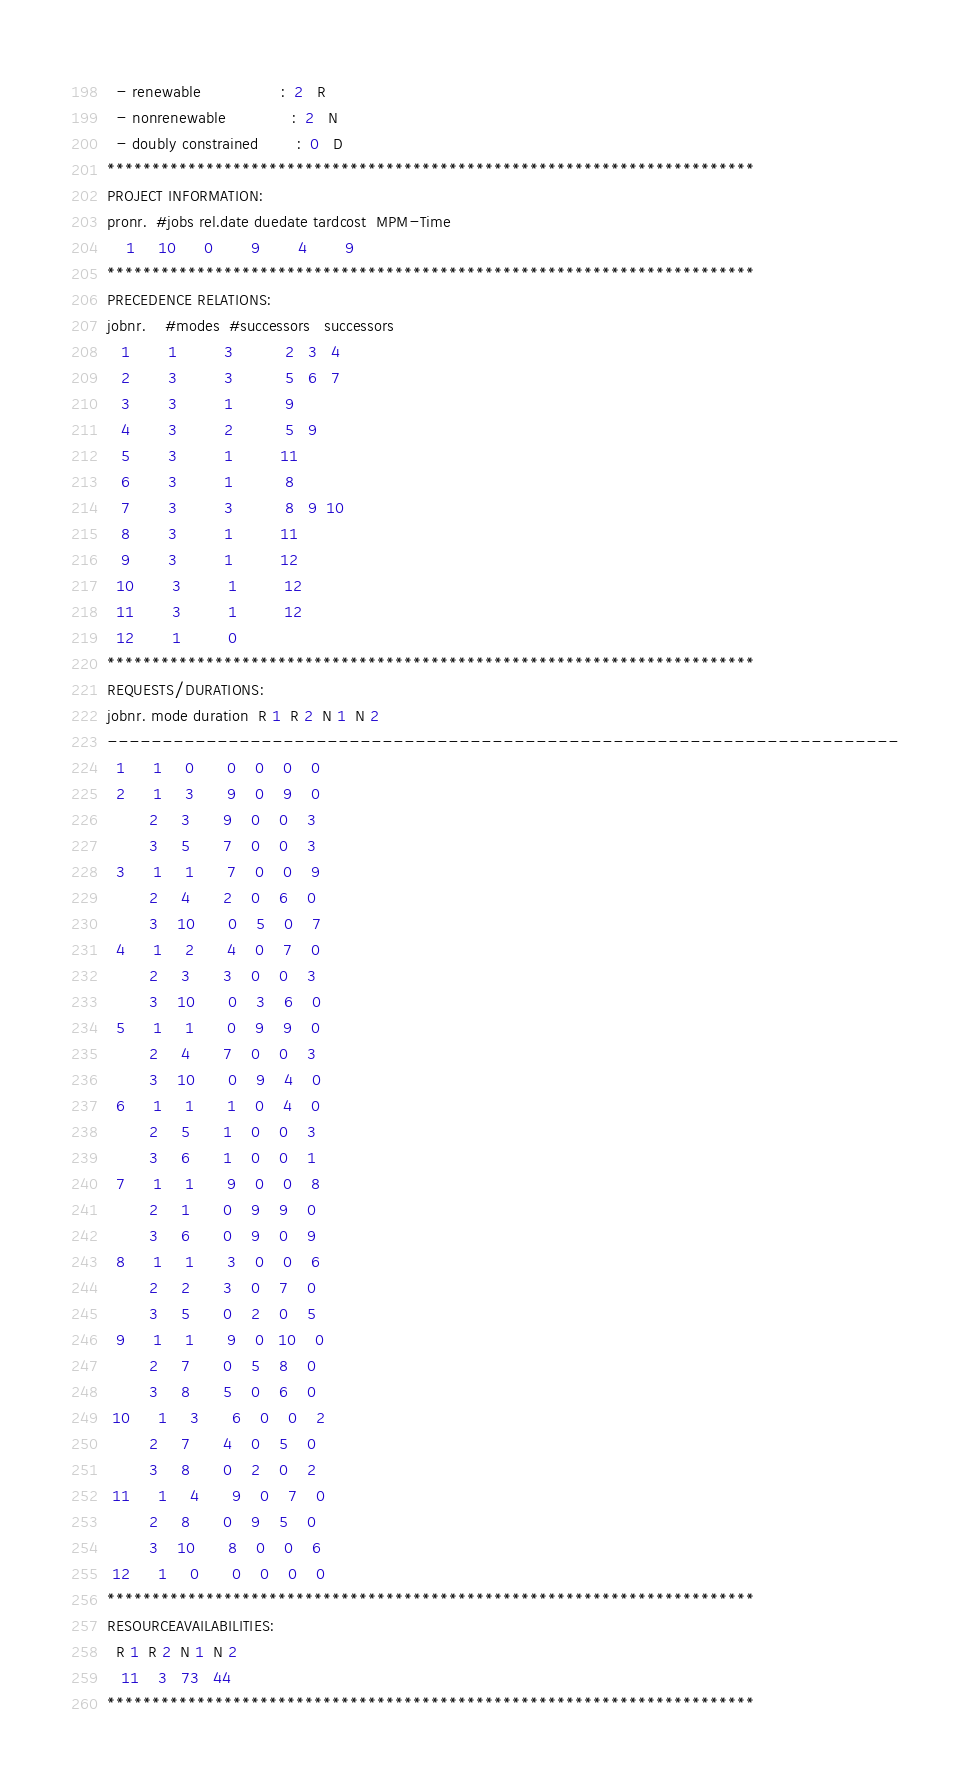Convert code to text. <code><loc_0><loc_0><loc_500><loc_500><_ObjectiveC_>  - renewable                 :  2   R
  - nonrenewable              :  2   N
  - doubly constrained        :  0   D
************************************************************************
PROJECT INFORMATION:
pronr.  #jobs rel.date duedate tardcost  MPM-Time
    1     10      0        9        4        9
************************************************************************
PRECEDENCE RELATIONS:
jobnr.    #modes  #successors   successors
   1        1          3           2   3   4
   2        3          3           5   6   7
   3        3          1           9
   4        3          2           5   9
   5        3          1          11
   6        3          1           8
   7        3          3           8   9  10
   8        3          1          11
   9        3          1          12
  10        3          1          12
  11        3          1          12
  12        1          0        
************************************************************************
REQUESTS/DURATIONS:
jobnr. mode duration  R 1  R 2  N 1  N 2
------------------------------------------------------------------------
  1      1     0       0    0    0    0
  2      1     3       9    0    9    0
         2     3       9    0    0    3
         3     5       7    0    0    3
  3      1     1       7    0    0    9
         2     4       2    0    6    0
         3    10       0    5    0    7
  4      1     2       4    0    7    0
         2     3       3    0    0    3
         3    10       0    3    6    0
  5      1     1       0    9    9    0
         2     4       7    0    0    3
         3    10       0    9    4    0
  6      1     1       1    0    4    0
         2     5       1    0    0    3
         3     6       1    0    0    1
  7      1     1       9    0    0    8
         2     1       0    9    9    0
         3     6       0    9    0    9
  8      1     1       3    0    0    6
         2     2       3    0    7    0
         3     5       0    2    0    5
  9      1     1       9    0   10    0
         2     7       0    5    8    0
         3     8       5    0    6    0
 10      1     3       6    0    0    2
         2     7       4    0    5    0
         3     8       0    2    0    2
 11      1     4       9    0    7    0
         2     8       0    9    5    0
         3    10       8    0    0    6
 12      1     0       0    0    0    0
************************************************************************
RESOURCEAVAILABILITIES:
  R 1  R 2  N 1  N 2
   11    3   73   44
************************************************************************
</code> 